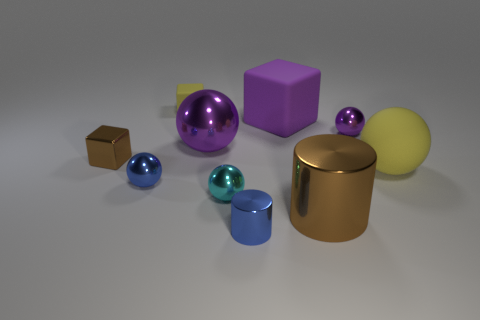Subtract 3 balls. How many balls are left? 2 Subtract all cyan spheres. How many spheres are left? 4 Subtract all purple spheres. How many spheres are left? 3 Subtract all red balls. Subtract all green cubes. How many balls are left? 5 Add 4 large purple balls. How many large purple balls are left? 5 Add 6 small blue metal spheres. How many small blue metal spheres exist? 7 Subtract 0 yellow cylinders. How many objects are left? 10 Subtract all cylinders. How many objects are left? 8 Subtract all small blocks. Subtract all big purple things. How many objects are left? 6 